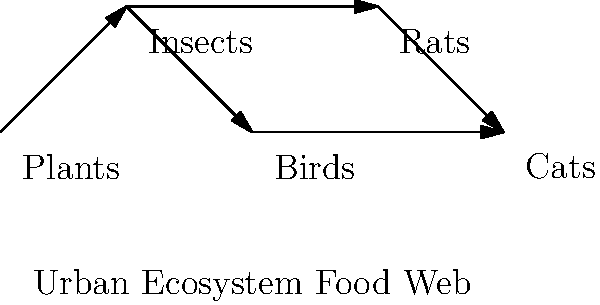In the urban ecosystem food web shown above, if the insect population suddenly decreases due to pesticide use, which of the following would be a direct consequence? To answer this question, we need to analyze the food web diagram and understand the direct relationships between organisms:

1. First, identify the position of insects in the food web:
   - Insects are primary consumers, feeding on plants.
   - Insects are prey for both birds and rats.

2. Consider the immediate effects of a decrease in insect population:
   - The organisms that directly feed on insects will be affected first.
   - In this food web, birds and rats are directly connected to insects.

3. Analyze the potential consequences:
   - Plants may experience less herbivory, but this is not a direct consequence of insect decrease.
   - Cats, being at the top of this food web, would be indirectly affected through changes in bird and rat populations.
   - Bird and rat populations would likely decrease due to loss of a primary food source.

4. Conclusion:
   The direct consequence would be a decrease in bird and rat populations, as they rely on insects as a food source.

This question tests the student's ability to interpret ecological relationships in an urban setting, combining aspects of ecology with the built environment - a key intersection of ecology and civil engineering.
Answer: Decrease in bird and rat populations 